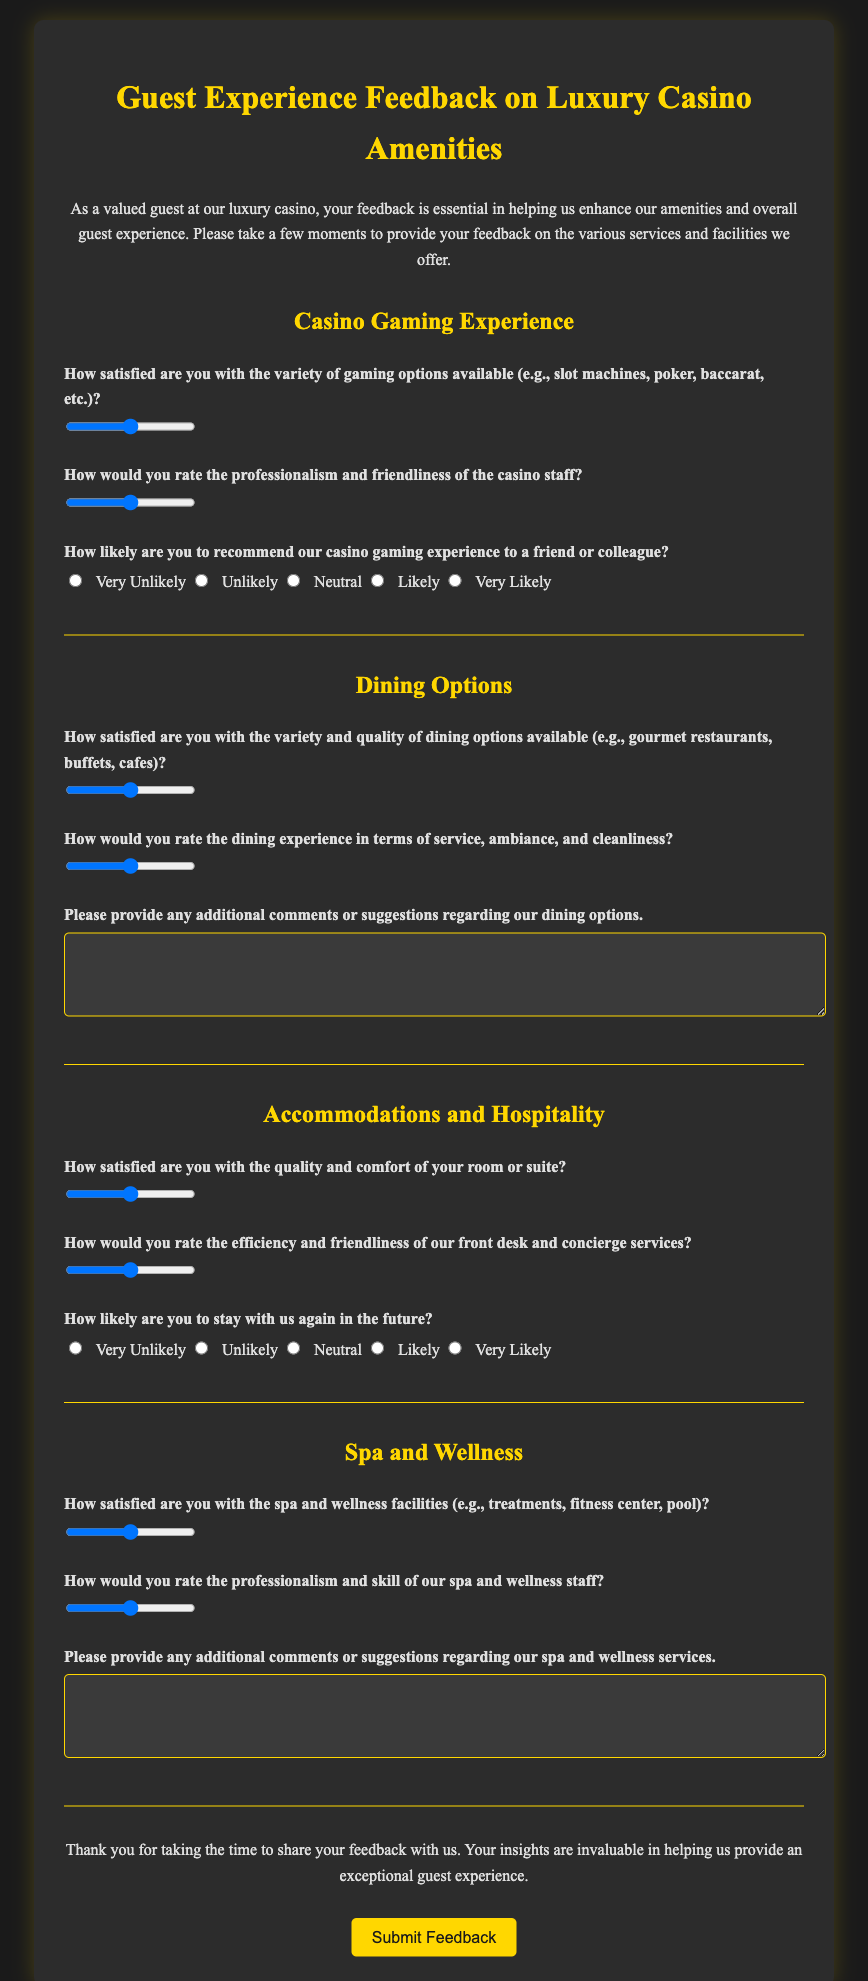What is the title of the survey? The title of the survey is prominently displayed at the top of the document, indicating the focus of the survey.
Answer: Guest Experience Feedback on Luxury Casino Amenities How many sections are in the survey? The survey is divided into categories, each representing different areas of guest experience, totaling four sections.
Answer: Four What is the minimum score for satisfaction ratings? The survey uses a range scoring system, and the lowest value that can be selected for satisfaction ratings is listed in the range inputs.
Answer: 1 What kind of input is used for recommending the casino gaming experience? The survey uses specific input types for guests to indicate their likelihood of recommending the gaming experience to others.
Answer: Radio buttons What amenities are included in the Spa and Wellness section? The question prompts guests to reflect on specific facilities offered as part of their wellness experience, which are mentioned in the question.
Answer: Treatments, fitness center, pool How does the survey ask about dining comments? The survey includes a question inviting guests to share additional feedback on a particular area of their experience, which is an open-ended text area.
Answer: Textarea What color scheme is used for the document? The overall aesthetic of the document incorporates specific colors that can be identified throughout the design.
Answer: Dark gray and gold Which aspect of service is addressed for front desk and concierge? The survey specifically requests feedback on the performance of staff in a particular area essential to guest hospitality.
Answer: Efficiency and friendliness 